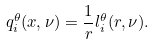<formula> <loc_0><loc_0><loc_500><loc_500>q _ { i } ^ { \theta } ( x , \nu ) = \frac { 1 } { r } l _ { i } ^ { \theta } ( r , \nu ) .</formula> 